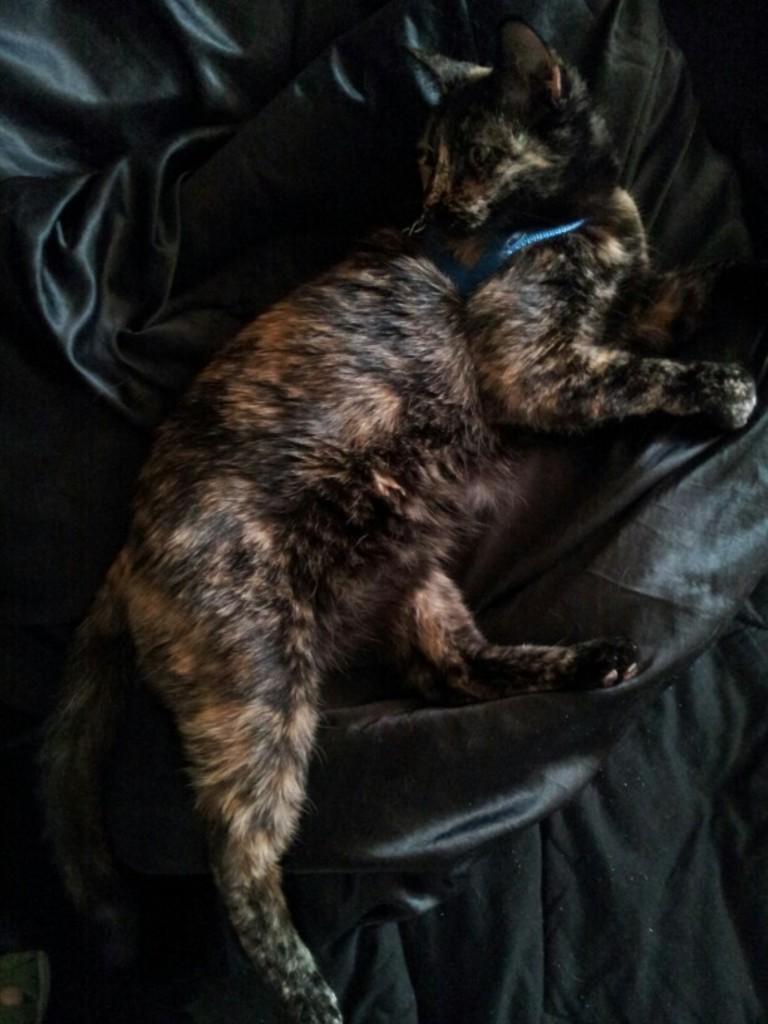Please provide a concise description of this image. In this image I can see a cat lying on a black color cloth. The cat is wearing some object. 